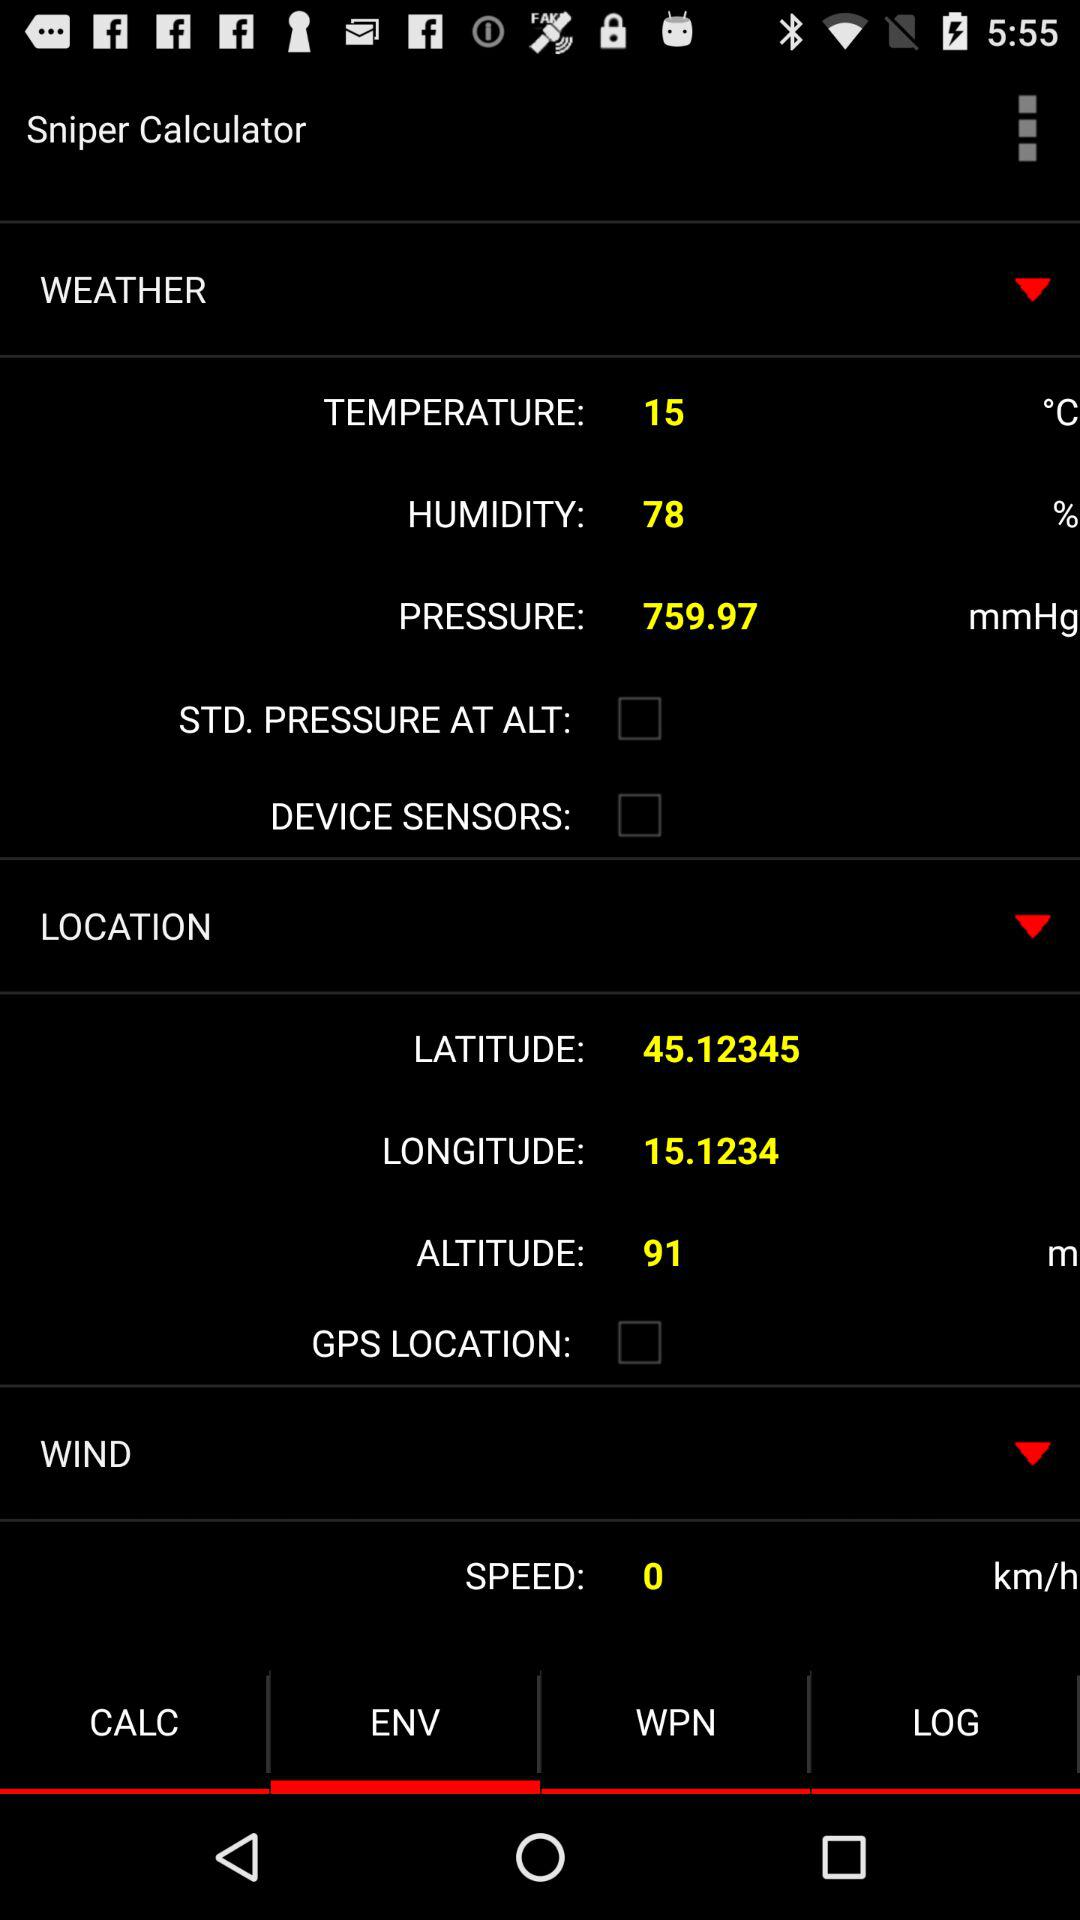What is the unit of wind speed? The unit of wind speed is kilometers per hour. 